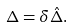<formula> <loc_0><loc_0><loc_500><loc_500>\Delta = \delta \hat { \Delta } .</formula> 